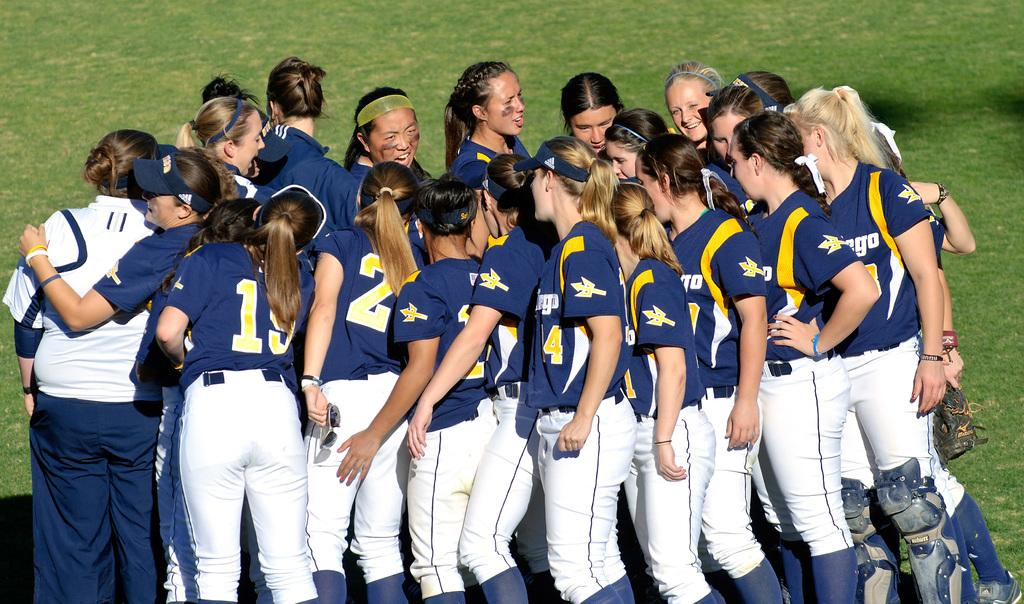<image>
Offer a succinct explanation of the picture presented. A bunch of female athletes wear uniforms with 19, 2, 4 and more on them. 